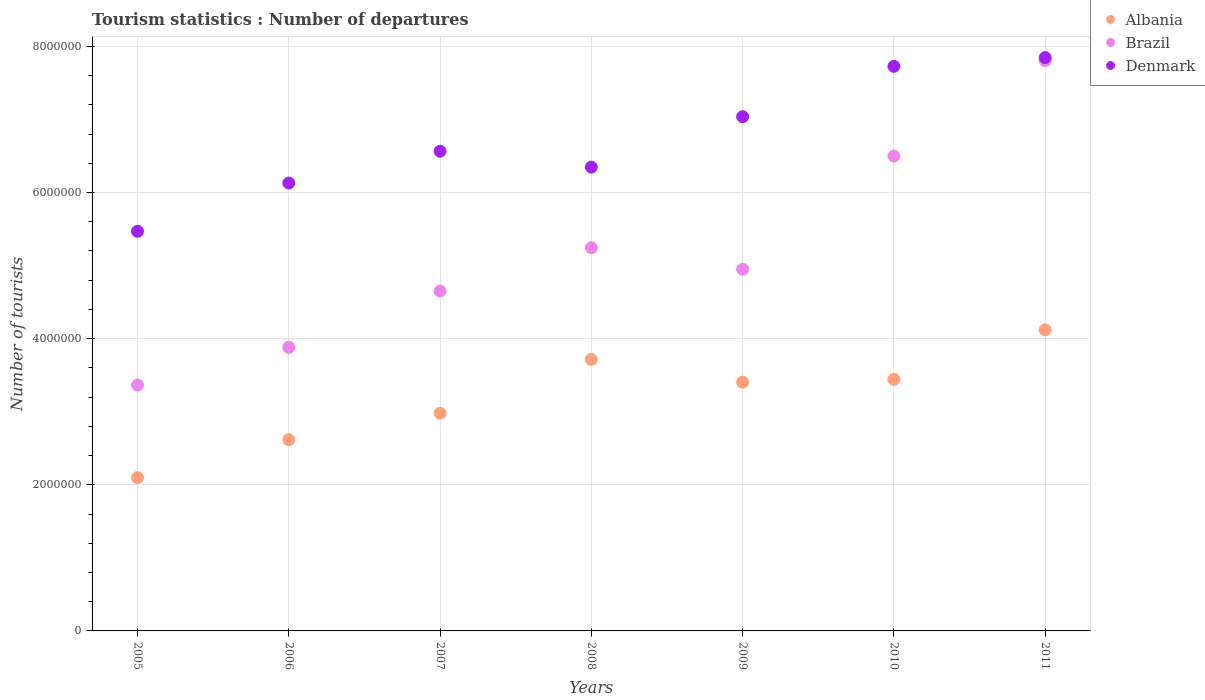How many different coloured dotlines are there?
Provide a succinct answer. 3. What is the number of tourist departures in Denmark in 2010?
Your answer should be very brief. 7.73e+06. Across all years, what is the maximum number of tourist departures in Albania?
Give a very brief answer. 4.12e+06. Across all years, what is the minimum number of tourist departures in Denmark?
Offer a very short reply. 5.47e+06. In which year was the number of tourist departures in Albania maximum?
Keep it short and to the point. 2011. What is the total number of tourist departures in Brazil in the graph?
Your response must be concise. 3.64e+07. What is the difference between the number of tourist departures in Albania in 2006 and that in 2011?
Give a very brief answer. -1.50e+06. What is the difference between the number of tourist departures in Albania in 2005 and the number of tourist departures in Brazil in 2009?
Keep it short and to the point. -2.85e+06. What is the average number of tourist departures in Albania per year?
Your response must be concise. 3.20e+06. In the year 2009, what is the difference between the number of tourist departures in Albania and number of tourist departures in Denmark?
Your answer should be compact. -3.63e+06. In how many years, is the number of tourist departures in Albania greater than 2800000?
Give a very brief answer. 5. What is the ratio of the number of tourist departures in Brazil in 2010 to that in 2011?
Make the answer very short. 0.83. Is the difference between the number of tourist departures in Albania in 2008 and 2011 greater than the difference between the number of tourist departures in Denmark in 2008 and 2011?
Provide a short and direct response. Yes. What is the difference between the highest and the second highest number of tourist departures in Albania?
Offer a terse response. 4.04e+05. What is the difference between the highest and the lowest number of tourist departures in Denmark?
Give a very brief answer. 2.38e+06. In how many years, is the number of tourist departures in Denmark greater than the average number of tourist departures in Denmark taken over all years?
Provide a succinct answer. 3. Is it the case that in every year, the sum of the number of tourist departures in Albania and number of tourist departures in Denmark  is greater than the number of tourist departures in Brazil?
Your answer should be compact. Yes. Does the graph contain any zero values?
Offer a terse response. No. Does the graph contain grids?
Give a very brief answer. Yes. What is the title of the graph?
Provide a short and direct response. Tourism statistics : Number of departures. Does "Guam" appear as one of the legend labels in the graph?
Provide a succinct answer. No. What is the label or title of the X-axis?
Give a very brief answer. Years. What is the label or title of the Y-axis?
Provide a short and direct response. Number of tourists. What is the Number of tourists of Albania in 2005?
Your answer should be compact. 2.10e+06. What is the Number of tourists in Brazil in 2005?
Your answer should be compact. 3.36e+06. What is the Number of tourists in Denmark in 2005?
Your answer should be compact. 5.47e+06. What is the Number of tourists of Albania in 2006?
Provide a succinct answer. 2.62e+06. What is the Number of tourists of Brazil in 2006?
Keep it short and to the point. 3.88e+06. What is the Number of tourists in Denmark in 2006?
Your answer should be compact. 6.13e+06. What is the Number of tourists in Albania in 2007?
Provide a succinct answer. 2.98e+06. What is the Number of tourists in Brazil in 2007?
Your answer should be very brief. 4.65e+06. What is the Number of tourists in Denmark in 2007?
Make the answer very short. 6.56e+06. What is the Number of tourists of Albania in 2008?
Keep it short and to the point. 3.72e+06. What is the Number of tourists of Brazil in 2008?
Offer a terse response. 5.24e+06. What is the Number of tourists of Denmark in 2008?
Give a very brief answer. 6.35e+06. What is the Number of tourists in Albania in 2009?
Offer a terse response. 3.40e+06. What is the Number of tourists in Brazil in 2009?
Your answer should be compact. 4.95e+06. What is the Number of tourists of Denmark in 2009?
Keep it short and to the point. 7.04e+06. What is the Number of tourists in Albania in 2010?
Provide a short and direct response. 3.44e+06. What is the Number of tourists of Brazil in 2010?
Make the answer very short. 6.50e+06. What is the Number of tourists in Denmark in 2010?
Your answer should be compact. 7.73e+06. What is the Number of tourists of Albania in 2011?
Offer a very short reply. 4.12e+06. What is the Number of tourists of Brazil in 2011?
Your response must be concise. 7.80e+06. What is the Number of tourists of Denmark in 2011?
Offer a terse response. 7.85e+06. Across all years, what is the maximum Number of tourists of Albania?
Provide a succinct answer. 4.12e+06. Across all years, what is the maximum Number of tourists of Brazil?
Your answer should be compact. 7.80e+06. Across all years, what is the maximum Number of tourists in Denmark?
Provide a short and direct response. 7.85e+06. Across all years, what is the minimum Number of tourists of Albania?
Make the answer very short. 2.10e+06. Across all years, what is the minimum Number of tourists in Brazil?
Offer a terse response. 3.36e+06. Across all years, what is the minimum Number of tourists in Denmark?
Your answer should be compact. 5.47e+06. What is the total Number of tourists in Albania in the graph?
Give a very brief answer. 2.24e+07. What is the total Number of tourists in Brazil in the graph?
Your answer should be very brief. 3.64e+07. What is the total Number of tourists of Denmark in the graph?
Keep it short and to the point. 4.71e+07. What is the difference between the Number of tourists of Albania in 2005 and that in 2006?
Provide a succinct answer. -5.19e+05. What is the difference between the Number of tourists in Brazil in 2005 and that in 2006?
Offer a terse response. -5.15e+05. What is the difference between the Number of tourists of Denmark in 2005 and that in 2006?
Your answer should be very brief. -6.60e+05. What is the difference between the Number of tourists of Albania in 2005 and that in 2007?
Provide a succinct answer. -8.82e+05. What is the difference between the Number of tourists of Brazil in 2005 and that in 2007?
Your answer should be compact. -1.29e+06. What is the difference between the Number of tourists in Denmark in 2005 and that in 2007?
Provide a succinct answer. -1.10e+06. What is the difference between the Number of tourists of Albania in 2005 and that in 2008?
Your response must be concise. -1.62e+06. What is the difference between the Number of tourists of Brazil in 2005 and that in 2008?
Provide a short and direct response. -1.88e+06. What is the difference between the Number of tourists in Denmark in 2005 and that in 2008?
Provide a succinct answer. -8.78e+05. What is the difference between the Number of tourists of Albania in 2005 and that in 2009?
Provide a succinct answer. -1.31e+06. What is the difference between the Number of tourists of Brazil in 2005 and that in 2009?
Offer a terse response. -1.58e+06. What is the difference between the Number of tourists of Denmark in 2005 and that in 2009?
Ensure brevity in your answer.  -1.57e+06. What is the difference between the Number of tourists of Albania in 2005 and that in 2010?
Your answer should be very brief. -1.35e+06. What is the difference between the Number of tourists in Brazil in 2005 and that in 2010?
Ensure brevity in your answer.  -3.13e+06. What is the difference between the Number of tourists in Denmark in 2005 and that in 2010?
Give a very brief answer. -2.26e+06. What is the difference between the Number of tourists of Albania in 2005 and that in 2011?
Offer a very short reply. -2.02e+06. What is the difference between the Number of tourists of Brazil in 2005 and that in 2011?
Keep it short and to the point. -4.44e+06. What is the difference between the Number of tourists in Denmark in 2005 and that in 2011?
Provide a succinct answer. -2.38e+06. What is the difference between the Number of tourists of Albania in 2006 and that in 2007?
Keep it short and to the point. -3.63e+05. What is the difference between the Number of tourists in Brazil in 2006 and that in 2007?
Keep it short and to the point. -7.71e+05. What is the difference between the Number of tourists of Denmark in 2006 and that in 2007?
Ensure brevity in your answer.  -4.35e+05. What is the difference between the Number of tourists of Albania in 2006 and that in 2008?
Keep it short and to the point. -1.10e+06. What is the difference between the Number of tourists of Brazil in 2006 and that in 2008?
Ensure brevity in your answer.  -1.36e+06. What is the difference between the Number of tourists in Denmark in 2006 and that in 2008?
Offer a very short reply. -2.18e+05. What is the difference between the Number of tourists in Albania in 2006 and that in 2009?
Your answer should be compact. -7.88e+05. What is the difference between the Number of tourists of Brazil in 2006 and that in 2009?
Keep it short and to the point. -1.07e+06. What is the difference between the Number of tourists of Denmark in 2006 and that in 2009?
Give a very brief answer. -9.08e+05. What is the difference between the Number of tourists of Albania in 2006 and that in 2010?
Provide a succinct answer. -8.27e+05. What is the difference between the Number of tourists of Brazil in 2006 and that in 2010?
Your answer should be very brief. -2.62e+06. What is the difference between the Number of tourists in Denmark in 2006 and that in 2010?
Your response must be concise. -1.60e+06. What is the difference between the Number of tourists of Albania in 2006 and that in 2011?
Make the answer very short. -1.50e+06. What is the difference between the Number of tourists in Brazil in 2006 and that in 2011?
Offer a very short reply. -3.92e+06. What is the difference between the Number of tourists of Denmark in 2006 and that in 2011?
Your answer should be compact. -1.72e+06. What is the difference between the Number of tourists of Albania in 2007 and that in 2008?
Your answer should be compact. -7.37e+05. What is the difference between the Number of tourists in Brazil in 2007 and that in 2008?
Ensure brevity in your answer.  -5.93e+05. What is the difference between the Number of tourists of Denmark in 2007 and that in 2008?
Keep it short and to the point. 2.17e+05. What is the difference between the Number of tourists in Albania in 2007 and that in 2009?
Give a very brief answer. -4.25e+05. What is the difference between the Number of tourists in Brazil in 2007 and that in 2009?
Your response must be concise. -2.99e+05. What is the difference between the Number of tourists of Denmark in 2007 and that in 2009?
Offer a terse response. -4.73e+05. What is the difference between the Number of tourists of Albania in 2007 and that in 2010?
Give a very brief answer. -4.64e+05. What is the difference between the Number of tourists of Brazil in 2007 and that in 2010?
Offer a very short reply. -1.85e+06. What is the difference between the Number of tourists in Denmark in 2007 and that in 2010?
Keep it short and to the point. -1.16e+06. What is the difference between the Number of tourists of Albania in 2007 and that in 2011?
Provide a short and direct response. -1.14e+06. What is the difference between the Number of tourists of Brazil in 2007 and that in 2011?
Offer a very short reply. -3.15e+06. What is the difference between the Number of tourists of Denmark in 2007 and that in 2011?
Keep it short and to the point. -1.28e+06. What is the difference between the Number of tourists in Albania in 2008 and that in 2009?
Your answer should be very brief. 3.12e+05. What is the difference between the Number of tourists in Brazil in 2008 and that in 2009?
Keep it short and to the point. 2.94e+05. What is the difference between the Number of tourists in Denmark in 2008 and that in 2009?
Ensure brevity in your answer.  -6.90e+05. What is the difference between the Number of tourists in Albania in 2008 and that in 2010?
Provide a short and direct response. 2.73e+05. What is the difference between the Number of tourists in Brazil in 2008 and that in 2010?
Offer a terse response. -1.25e+06. What is the difference between the Number of tourists in Denmark in 2008 and that in 2010?
Offer a terse response. -1.38e+06. What is the difference between the Number of tourists in Albania in 2008 and that in 2011?
Provide a short and direct response. -4.04e+05. What is the difference between the Number of tourists in Brazil in 2008 and that in 2011?
Ensure brevity in your answer.  -2.56e+06. What is the difference between the Number of tourists in Denmark in 2008 and that in 2011?
Ensure brevity in your answer.  -1.50e+06. What is the difference between the Number of tourists of Albania in 2009 and that in 2010?
Your answer should be very brief. -3.90e+04. What is the difference between the Number of tourists of Brazil in 2009 and that in 2010?
Give a very brief answer. -1.55e+06. What is the difference between the Number of tourists of Denmark in 2009 and that in 2010?
Ensure brevity in your answer.  -6.89e+05. What is the difference between the Number of tourists in Albania in 2009 and that in 2011?
Keep it short and to the point. -7.16e+05. What is the difference between the Number of tourists in Brazil in 2009 and that in 2011?
Provide a short and direct response. -2.86e+06. What is the difference between the Number of tourists of Denmark in 2009 and that in 2011?
Offer a very short reply. -8.09e+05. What is the difference between the Number of tourists of Albania in 2010 and that in 2011?
Make the answer very short. -6.77e+05. What is the difference between the Number of tourists in Brazil in 2010 and that in 2011?
Your answer should be compact. -1.31e+06. What is the difference between the Number of tourists of Albania in 2005 and the Number of tourists of Brazil in 2006?
Your response must be concise. -1.78e+06. What is the difference between the Number of tourists in Albania in 2005 and the Number of tourists in Denmark in 2006?
Offer a very short reply. -4.03e+06. What is the difference between the Number of tourists in Brazil in 2005 and the Number of tourists in Denmark in 2006?
Offer a terse response. -2.76e+06. What is the difference between the Number of tourists in Albania in 2005 and the Number of tourists in Brazil in 2007?
Offer a terse response. -2.55e+06. What is the difference between the Number of tourists in Albania in 2005 and the Number of tourists in Denmark in 2007?
Your answer should be compact. -4.47e+06. What is the difference between the Number of tourists of Brazil in 2005 and the Number of tourists of Denmark in 2007?
Give a very brief answer. -3.20e+06. What is the difference between the Number of tourists in Albania in 2005 and the Number of tourists in Brazil in 2008?
Give a very brief answer. -3.15e+06. What is the difference between the Number of tourists in Albania in 2005 and the Number of tourists in Denmark in 2008?
Your response must be concise. -4.25e+06. What is the difference between the Number of tourists of Brazil in 2005 and the Number of tourists of Denmark in 2008?
Give a very brief answer. -2.98e+06. What is the difference between the Number of tourists of Albania in 2005 and the Number of tourists of Brazil in 2009?
Provide a short and direct response. -2.85e+06. What is the difference between the Number of tourists of Albania in 2005 and the Number of tourists of Denmark in 2009?
Your answer should be very brief. -4.94e+06. What is the difference between the Number of tourists in Brazil in 2005 and the Number of tourists in Denmark in 2009?
Make the answer very short. -3.67e+06. What is the difference between the Number of tourists of Albania in 2005 and the Number of tourists of Brazil in 2010?
Provide a short and direct response. -4.40e+06. What is the difference between the Number of tourists in Albania in 2005 and the Number of tourists in Denmark in 2010?
Your answer should be compact. -5.63e+06. What is the difference between the Number of tourists of Brazil in 2005 and the Number of tourists of Denmark in 2010?
Make the answer very short. -4.36e+06. What is the difference between the Number of tourists of Albania in 2005 and the Number of tourists of Brazil in 2011?
Provide a succinct answer. -5.71e+06. What is the difference between the Number of tourists in Albania in 2005 and the Number of tourists in Denmark in 2011?
Your answer should be compact. -5.75e+06. What is the difference between the Number of tourists of Brazil in 2005 and the Number of tourists of Denmark in 2011?
Give a very brief answer. -4.48e+06. What is the difference between the Number of tourists in Albania in 2006 and the Number of tourists in Brazil in 2007?
Ensure brevity in your answer.  -2.04e+06. What is the difference between the Number of tourists in Albania in 2006 and the Number of tourists in Denmark in 2007?
Give a very brief answer. -3.95e+06. What is the difference between the Number of tourists of Brazil in 2006 and the Number of tourists of Denmark in 2007?
Ensure brevity in your answer.  -2.68e+06. What is the difference between the Number of tourists of Albania in 2006 and the Number of tourists of Brazil in 2008?
Ensure brevity in your answer.  -2.63e+06. What is the difference between the Number of tourists of Albania in 2006 and the Number of tourists of Denmark in 2008?
Ensure brevity in your answer.  -3.73e+06. What is the difference between the Number of tourists in Brazil in 2006 and the Number of tourists in Denmark in 2008?
Your answer should be very brief. -2.47e+06. What is the difference between the Number of tourists of Albania in 2006 and the Number of tourists of Brazil in 2009?
Offer a terse response. -2.33e+06. What is the difference between the Number of tourists of Albania in 2006 and the Number of tourists of Denmark in 2009?
Offer a terse response. -4.42e+06. What is the difference between the Number of tourists of Brazil in 2006 and the Number of tourists of Denmark in 2009?
Your response must be concise. -3.16e+06. What is the difference between the Number of tourists of Albania in 2006 and the Number of tourists of Brazil in 2010?
Provide a succinct answer. -3.88e+06. What is the difference between the Number of tourists of Albania in 2006 and the Number of tourists of Denmark in 2010?
Your response must be concise. -5.11e+06. What is the difference between the Number of tourists in Brazil in 2006 and the Number of tourists in Denmark in 2010?
Your answer should be compact. -3.85e+06. What is the difference between the Number of tourists of Albania in 2006 and the Number of tourists of Brazil in 2011?
Make the answer very short. -5.19e+06. What is the difference between the Number of tourists of Albania in 2006 and the Number of tourists of Denmark in 2011?
Give a very brief answer. -5.23e+06. What is the difference between the Number of tourists in Brazil in 2006 and the Number of tourists in Denmark in 2011?
Make the answer very short. -3.97e+06. What is the difference between the Number of tourists of Albania in 2007 and the Number of tourists of Brazil in 2008?
Provide a short and direct response. -2.26e+06. What is the difference between the Number of tourists of Albania in 2007 and the Number of tourists of Denmark in 2008?
Keep it short and to the point. -3.37e+06. What is the difference between the Number of tourists of Brazil in 2007 and the Number of tourists of Denmark in 2008?
Your response must be concise. -1.70e+06. What is the difference between the Number of tourists in Albania in 2007 and the Number of tourists in Brazil in 2009?
Keep it short and to the point. -1.97e+06. What is the difference between the Number of tourists in Albania in 2007 and the Number of tourists in Denmark in 2009?
Your answer should be compact. -4.06e+06. What is the difference between the Number of tourists in Brazil in 2007 and the Number of tourists in Denmark in 2009?
Offer a very short reply. -2.39e+06. What is the difference between the Number of tourists in Albania in 2007 and the Number of tourists in Brazil in 2010?
Ensure brevity in your answer.  -3.52e+06. What is the difference between the Number of tourists in Albania in 2007 and the Number of tourists in Denmark in 2010?
Provide a succinct answer. -4.75e+06. What is the difference between the Number of tourists in Brazil in 2007 and the Number of tourists in Denmark in 2010?
Your answer should be very brief. -3.08e+06. What is the difference between the Number of tourists in Albania in 2007 and the Number of tourists in Brazil in 2011?
Keep it short and to the point. -4.83e+06. What is the difference between the Number of tourists in Albania in 2007 and the Number of tourists in Denmark in 2011?
Your answer should be compact. -4.87e+06. What is the difference between the Number of tourists of Brazil in 2007 and the Number of tourists of Denmark in 2011?
Make the answer very short. -3.20e+06. What is the difference between the Number of tourists of Albania in 2008 and the Number of tourists of Brazil in 2009?
Offer a very short reply. -1.23e+06. What is the difference between the Number of tourists in Albania in 2008 and the Number of tourists in Denmark in 2009?
Your answer should be compact. -3.32e+06. What is the difference between the Number of tourists of Brazil in 2008 and the Number of tourists of Denmark in 2009?
Provide a short and direct response. -1.79e+06. What is the difference between the Number of tourists of Albania in 2008 and the Number of tourists of Brazil in 2010?
Provide a short and direct response. -2.78e+06. What is the difference between the Number of tourists of Albania in 2008 and the Number of tourists of Denmark in 2010?
Your answer should be very brief. -4.01e+06. What is the difference between the Number of tourists of Brazil in 2008 and the Number of tourists of Denmark in 2010?
Your answer should be compact. -2.48e+06. What is the difference between the Number of tourists in Albania in 2008 and the Number of tourists in Brazil in 2011?
Your answer should be compact. -4.09e+06. What is the difference between the Number of tourists of Albania in 2008 and the Number of tourists of Denmark in 2011?
Offer a very short reply. -4.13e+06. What is the difference between the Number of tourists in Brazil in 2008 and the Number of tourists in Denmark in 2011?
Provide a short and direct response. -2.60e+06. What is the difference between the Number of tourists of Albania in 2009 and the Number of tourists of Brazil in 2010?
Make the answer very short. -3.09e+06. What is the difference between the Number of tourists of Albania in 2009 and the Number of tourists of Denmark in 2010?
Ensure brevity in your answer.  -4.32e+06. What is the difference between the Number of tourists in Brazil in 2009 and the Number of tourists in Denmark in 2010?
Ensure brevity in your answer.  -2.78e+06. What is the difference between the Number of tourists of Albania in 2009 and the Number of tourists of Brazil in 2011?
Your answer should be compact. -4.40e+06. What is the difference between the Number of tourists of Albania in 2009 and the Number of tourists of Denmark in 2011?
Your answer should be very brief. -4.44e+06. What is the difference between the Number of tourists in Brazil in 2009 and the Number of tourists in Denmark in 2011?
Provide a short and direct response. -2.90e+06. What is the difference between the Number of tourists in Albania in 2010 and the Number of tourists in Brazil in 2011?
Provide a succinct answer. -4.36e+06. What is the difference between the Number of tourists in Albania in 2010 and the Number of tourists in Denmark in 2011?
Your answer should be compact. -4.40e+06. What is the difference between the Number of tourists in Brazil in 2010 and the Number of tourists in Denmark in 2011?
Provide a succinct answer. -1.35e+06. What is the average Number of tourists of Albania per year?
Your answer should be very brief. 3.20e+06. What is the average Number of tourists in Brazil per year?
Offer a very short reply. 5.20e+06. What is the average Number of tourists of Denmark per year?
Your answer should be compact. 6.73e+06. In the year 2005, what is the difference between the Number of tourists in Albania and Number of tourists in Brazil?
Offer a terse response. -1.27e+06. In the year 2005, what is the difference between the Number of tourists in Albania and Number of tourists in Denmark?
Your response must be concise. -3.37e+06. In the year 2005, what is the difference between the Number of tourists of Brazil and Number of tourists of Denmark?
Keep it short and to the point. -2.10e+06. In the year 2006, what is the difference between the Number of tourists of Albania and Number of tourists of Brazil?
Provide a succinct answer. -1.26e+06. In the year 2006, what is the difference between the Number of tourists in Albania and Number of tourists in Denmark?
Offer a terse response. -3.51e+06. In the year 2006, what is the difference between the Number of tourists in Brazil and Number of tourists in Denmark?
Offer a very short reply. -2.25e+06. In the year 2007, what is the difference between the Number of tourists in Albania and Number of tourists in Brazil?
Give a very brief answer. -1.67e+06. In the year 2007, what is the difference between the Number of tourists in Albania and Number of tourists in Denmark?
Offer a terse response. -3.58e+06. In the year 2007, what is the difference between the Number of tourists in Brazil and Number of tourists in Denmark?
Ensure brevity in your answer.  -1.91e+06. In the year 2008, what is the difference between the Number of tourists of Albania and Number of tourists of Brazil?
Give a very brief answer. -1.53e+06. In the year 2008, what is the difference between the Number of tourists in Albania and Number of tourists in Denmark?
Offer a terse response. -2.63e+06. In the year 2008, what is the difference between the Number of tourists in Brazil and Number of tourists in Denmark?
Provide a succinct answer. -1.10e+06. In the year 2009, what is the difference between the Number of tourists in Albania and Number of tourists in Brazil?
Keep it short and to the point. -1.55e+06. In the year 2009, what is the difference between the Number of tourists in Albania and Number of tourists in Denmark?
Your answer should be compact. -3.63e+06. In the year 2009, what is the difference between the Number of tourists in Brazil and Number of tourists in Denmark?
Make the answer very short. -2.09e+06. In the year 2010, what is the difference between the Number of tourists of Albania and Number of tourists of Brazil?
Give a very brief answer. -3.06e+06. In the year 2010, what is the difference between the Number of tourists of Albania and Number of tourists of Denmark?
Your answer should be very brief. -4.28e+06. In the year 2010, what is the difference between the Number of tourists of Brazil and Number of tourists of Denmark?
Offer a terse response. -1.23e+06. In the year 2011, what is the difference between the Number of tourists of Albania and Number of tourists of Brazil?
Provide a succinct answer. -3.68e+06. In the year 2011, what is the difference between the Number of tourists of Albania and Number of tourists of Denmark?
Keep it short and to the point. -3.73e+06. In the year 2011, what is the difference between the Number of tourists in Brazil and Number of tourists in Denmark?
Ensure brevity in your answer.  -4.10e+04. What is the ratio of the Number of tourists in Albania in 2005 to that in 2006?
Give a very brief answer. 0.8. What is the ratio of the Number of tourists of Brazil in 2005 to that in 2006?
Your answer should be very brief. 0.87. What is the ratio of the Number of tourists of Denmark in 2005 to that in 2006?
Keep it short and to the point. 0.89. What is the ratio of the Number of tourists in Albania in 2005 to that in 2007?
Your answer should be very brief. 0.7. What is the ratio of the Number of tourists in Brazil in 2005 to that in 2007?
Your response must be concise. 0.72. What is the ratio of the Number of tourists in Denmark in 2005 to that in 2007?
Provide a short and direct response. 0.83. What is the ratio of the Number of tourists of Albania in 2005 to that in 2008?
Ensure brevity in your answer.  0.56. What is the ratio of the Number of tourists of Brazil in 2005 to that in 2008?
Your answer should be compact. 0.64. What is the ratio of the Number of tourists in Denmark in 2005 to that in 2008?
Offer a very short reply. 0.86. What is the ratio of the Number of tourists of Albania in 2005 to that in 2009?
Provide a short and direct response. 0.62. What is the ratio of the Number of tourists in Brazil in 2005 to that in 2009?
Provide a succinct answer. 0.68. What is the ratio of the Number of tourists in Denmark in 2005 to that in 2009?
Your answer should be compact. 0.78. What is the ratio of the Number of tourists of Albania in 2005 to that in 2010?
Your response must be concise. 0.61. What is the ratio of the Number of tourists in Brazil in 2005 to that in 2010?
Make the answer very short. 0.52. What is the ratio of the Number of tourists of Denmark in 2005 to that in 2010?
Ensure brevity in your answer.  0.71. What is the ratio of the Number of tourists of Albania in 2005 to that in 2011?
Your response must be concise. 0.51. What is the ratio of the Number of tourists of Brazil in 2005 to that in 2011?
Provide a short and direct response. 0.43. What is the ratio of the Number of tourists of Denmark in 2005 to that in 2011?
Offer a terse response. 0.7. What is the ratio of the Number of tourists in Albania in 2006 to that in 2007?
Provide a short and direct response. 0.88. What is the ratio of the Number of tourists in Brazil in 2006 to that in 2007?
Give a very brief answer. 0.83. What is the ratio of the Number of tourists of Denmark in 2006 to that in 2007?
Give a very brief answer. 0.93. What is the ratio of the Number of tourists in Albania in 2006 to that in 2008?
Make the answer very short. 0.7. What is the ratio of the Number of tourists of Brazil in 2006 to that in 2008?
Offer a very short reply. 0.74. What is the ratio of the Number of tourists in Denmark in 2006 to that in 2008?
Offer a terse response. 0.97. What is the ratio of the Number of tourists of Albania in 2006 to that in 2009?
Ensure brevity in your answer.  0.77. What is the ratio of the Number of tourists of Brazil in 2006 to that in 2009?
Provide a succinct answer. 0.78. What is the ratio of the Number of tourists in Denmark in 2006 to that in 2009?
Make the answer very short. 0.87. What is the ratio of the Number of tourists of Albania in 2006 to that in 2010?
Your response must be concise. 0.76. What is the ratio of the Number of tourists in Brazil in 2006 to that in 2010?
Give a very brief answer. 0.6. What is the ratio of the Number of tourists in Denmark in 2006 to that in 2010?
Offer a very short reply. 0.79. What is the ratio of the Number of tourists in Albania in 2006 to that in 2011?
Your answer should be compact. 0.64. What is the ratio of the Number of tourists in Brazil in 2006 to that in 2011?
Your response must be concise. 0.5. What is the ratio of the Number of tourists in Denmark in 2006 to that in 2011?
Make the answer very short. 0.78. What is the ratio of the Number of tourists in Albania in 2007 to that in 2008?
Offer a terse response. 0.8. What is the ratio of the Number of tourists of Brazil in 2007 to that in 2008?
Provide a short and direct response. 0.89. What is the ratio of the Number of tourists of Denmark in 2007 to that in 2008?
Offer a very short reply. 1.03. What is the ratio of the Number of tourists of Albania in 2007 to that in 2009?
Give a very brief answer. 0.88. What is the ratio of the Number of tourists of Brazil in 2007 to that in 2009?
Provide a succinct answer. 0.94. What is the ratio of the Number of tourists in Denmark in 2007 to that in 2009?
Ensure brevity in your answer.  0.93. What is the ratio of the Number of tourists of Albania in 2007 to that in 2010?
Your response must be concise. 0.87. What is the ratio of the Number of tourists of Brazil in 2007 to that in 2010?
Your response must be concise. 0.72. What is the ratio of the Number of tourists in Denmark in 2007 to that in 2010?
Give a very brief answer. 0.85. What is the ratio of the Number of tourists of Albania in 2007 to that in 2011?
Provide a succinct answer. 0.72. What is the ratio of the Number of tourists of Brazil in 2007 to that in 2011?
Your answer should be compact. 0.6. What is the ratio of the Number of tourists of Denmark in 2007 to that in 2011?
Offer a terse response. 0.84. What is the ratio of the Number of tourists of Albania in 2008 to that in 2009?
Your answer should be compact. 1.09. What is the ratio of the Number of tourists in Brazil in 2008 to that in 2009?
Your answer should be very brief. 1.06. What is the ratio of the Number of tourists of Denmark in 2008 to that in 2009?
Keep it short and to the point. 0.9. What is the ratio of the Number of tourists of Albania in 2008 to that in 2010?
Ensure brevity in your answer.  1.08. What is the ratio of the Number of tourists of Brazil in 2008 to that in 2010?
Your response must be concise. 0.81. What is the ratio of the Number of tourists of Denmark in 2008 to that in 2010?
Offer a terse response. 0.82. What is the ratio of the Number of tourists of Albania in 2008 to that in 2011?
Give a very brief answer. 0.9. What is the ratio of the Number of tourists of Brazil in 2008 to that in 2011?
Give a very brief answer. 0.67. What is the ratio of the Number of tourists of Denmark in 2008 to that in 2011?
Your answer should be compact. 0.81. What is the ratio of the Number of tourists of Albania in 2009 to that in 2010?
Ensure brevity in your answer.  0.99. What is the ratio of the Number of tourists in Brazil in 2009 to that in 2010?
Make the answer very short. 0.76. What is the ratio of the Number of tourists in Denmark in 2009 to that in 2010?
Offer a very short reply. 0.91. What is the ratio of the Number of tourists of Albania in 2009 to that in 2011?
Give a very brief answer. 0.83. What is the ratio of the Number of tourists of Brazil in 2009 to that in 2011?
Ensure brevity in your answer.  0.63. What is the ratio of the Number of tourists in Denmark in 2009 to that in 2011?
Your response must be concise. 0.9. What is the ratio of the Number of tourists of Albania in 2010 to that in 2011?
Provide a succinct answer. 0.84. What is the ratio of the Number of tourists in Brazil in 2010 to that in 2011?
Ensure brevity in your answer.  0.83. What is the ratio of the Number of tourists in Denmark in 2010 to that in 2011?
Provide a succinct answer. 0.98. What is the difference between the highest and the second highest Number of tourists of Albania?
Make the answer very short. 4.04e+05. What is the difference between the highest and the second highest Number of tourists in Brazil?
Your answer should be very brief. 1.31e+06. What is the difference between the highest and the second highest Number of tourists of Denmark?
Offer a very short reply. 1.20e+05. What is the difference between the highest and the lowest Number of tourists in Albania?
Make the answer very short. 2.02e+06. What is the difference between the highest and the lowest Number of tourists of Brazil?
Your response must be concise. 4.44e+06. What is the difference between the highest and the lowest Number of tourists of Denmark?
Offer a very short reply. 2.38e+06. 